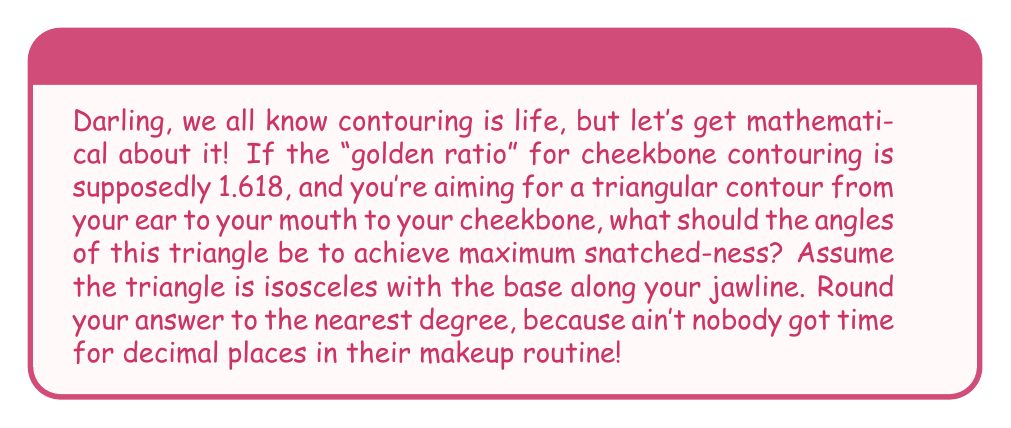Solve this math problem. Alright, beauty math gurus, let's break this down:

1) We're dealing with an isosceles triangle here. In an isosceles triangle, two angles are equal.

2) The golden ratio (φ) is approximately 1.618. This means the ratio of the length of the equal sides to the base should be 1.618.

3) In an isosceles triangle with golden ratio proportions:
   $$\frac{a}{b} = φ ≈ 1.618$$
   where $a$ is the length of the equal sides and $b$ is the length of the base.

4) In any triangle, the sum of all angles is 180°. Let's call the base angle $x$ and the top angle $y$:
   $$2x + y = 180°$$

5) Now, let's use the law of sines:
   $$\frac{b}{\sin y} = \frac{a}{\sin x}$$

6) Substituting our golden ratio:
   $$\frac{1}{\sin y} = \frac{1.618}{\sin x}$$

7) Simplifying:
   $$\sin y = \frac{\sin x}{1.618}$$

8) Using the identity $\sin (180° - 2x) = \sin 2x$:
   $$\sin 2x = \frac{\sin x}{1.618}$$

9) This equation can be solved numerically to give $x ≈ 51.827°$

10) Therefore, $y = 180° - 2x ≈ 76.346°$

11) Rounding to the nearest degree:
    $x = 52°$ and $y = 76°$
Answer: 52°, 52°, 76° 